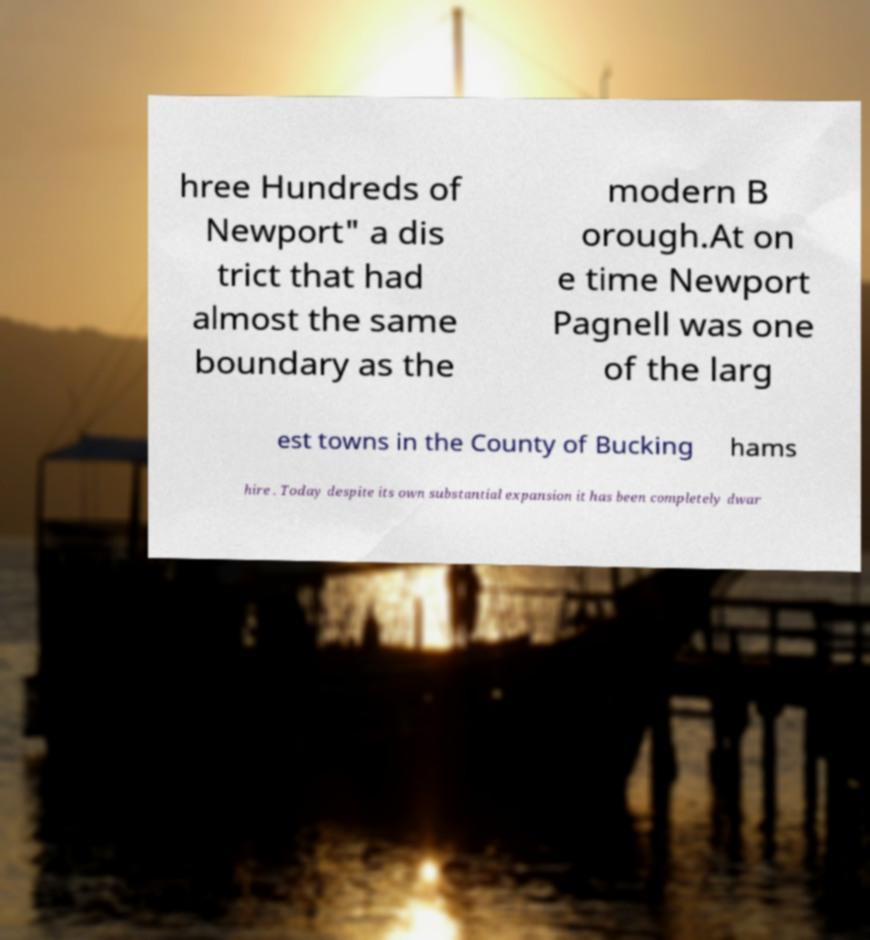Could you extract and type out the text from this image? hree Hundreds of Newport" a dis trict that had almost the same boundary as the modern B orough.At on e time Newport Pagnell was one of the larg est towns in the County of Bucking hams hire . Today despite its own substantial expansion it has been completely dwar 